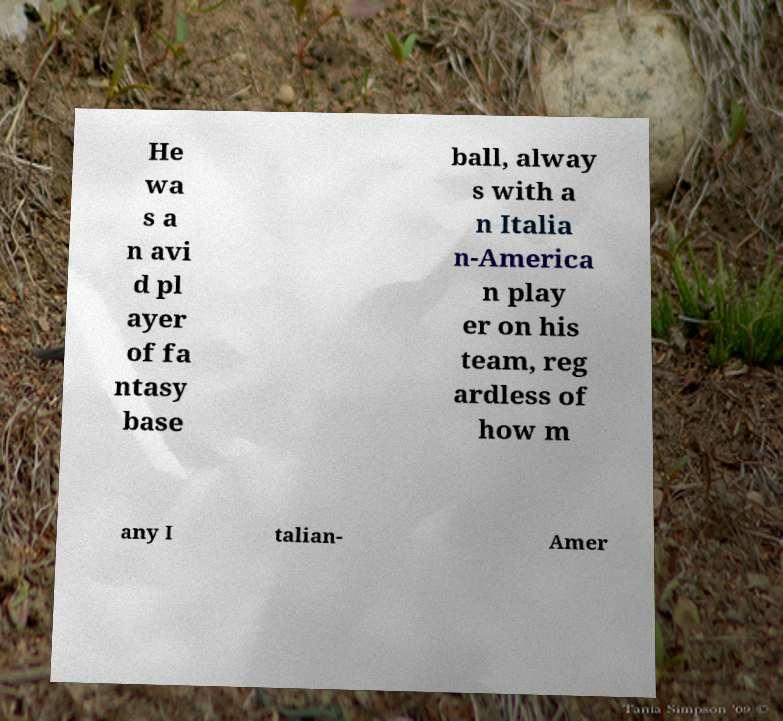I need the written content from this picture converted into text. Can you do that? He wa s a n avi d pl ayer of fa ntasy base ball, alway s with a n Italia n-America n play er on his team, reg ardless of how m any I talian- Amer 